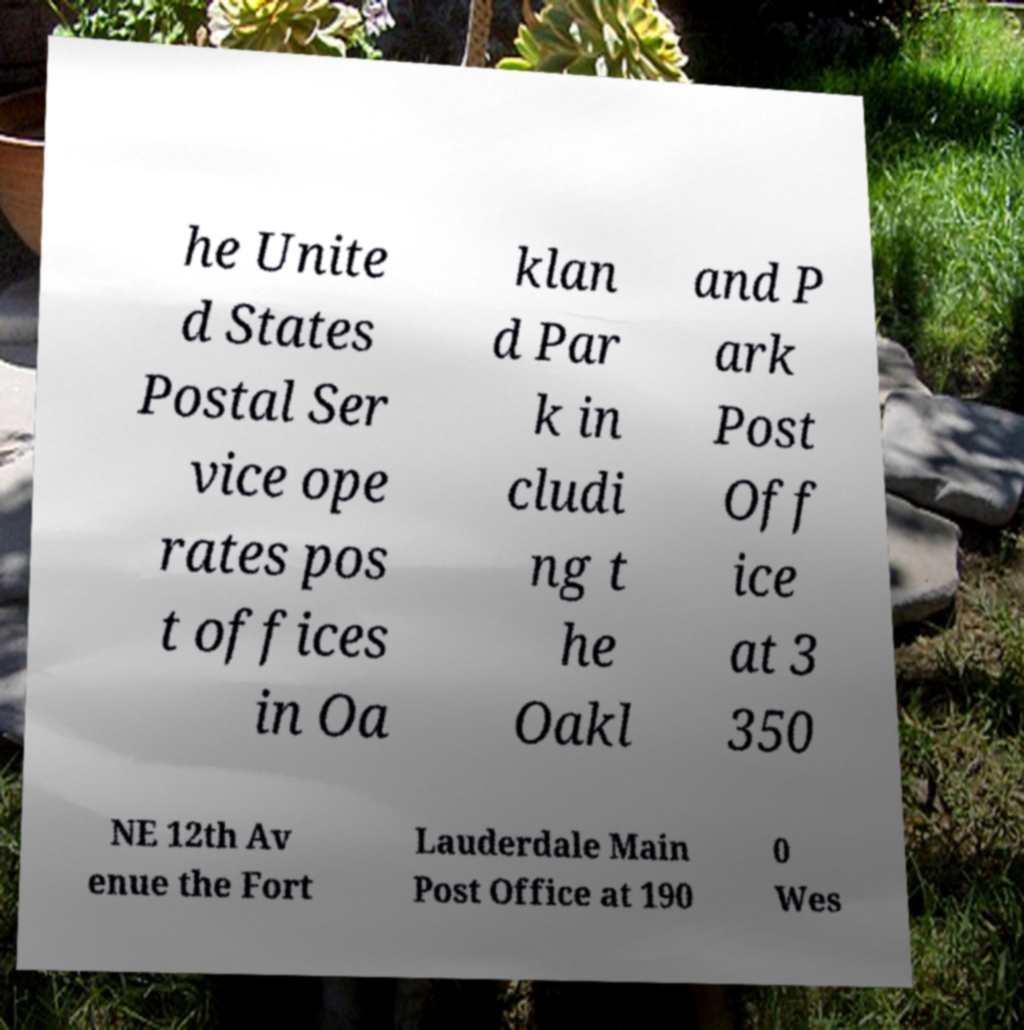Could you assist in decoding the text presented in this image and type it out clearly? he Unite d States Postal Ser vice ope rates pos t offices in Oa klan d Par k in cludi ng t he Oakl and P ark Post Off ice at 3 350 NE 12th Av enue the Fort Lauderdale Main Post Office at 190 0 Wes 